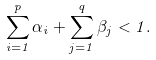<formula> <loc_0><loc_0><loc_500><loc_500>\sum _ { i = 1 } ^ { p } \alpha _ { i } + \sum _ { j = 1 } ^ { q } \beta _ { j } < 1 .</formula> 